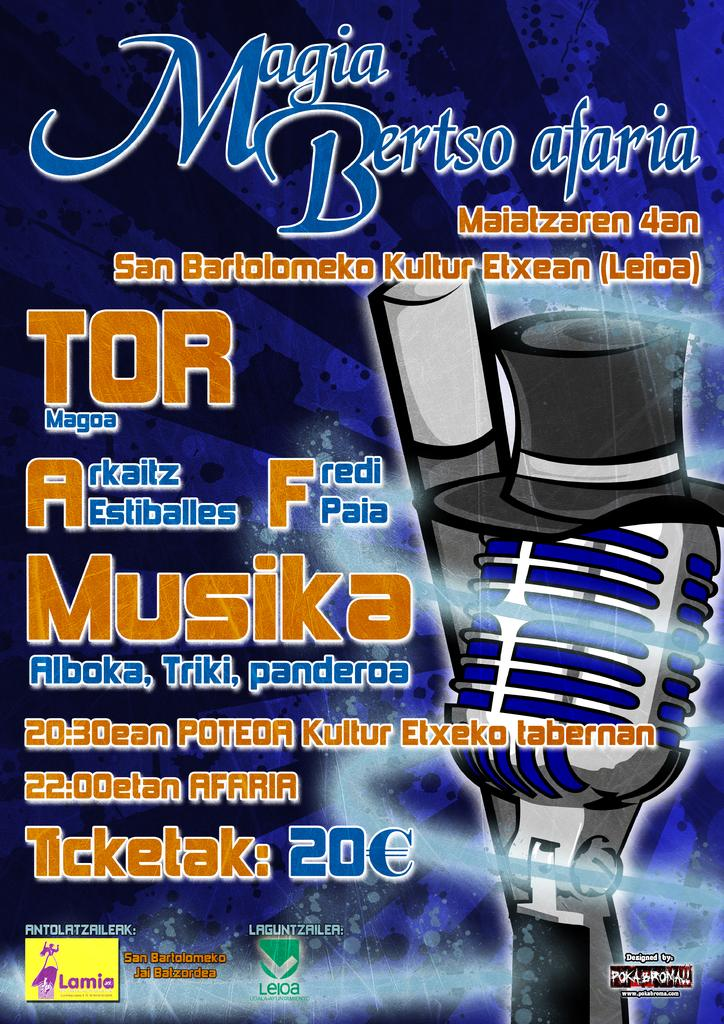<image>
Describe the image concisely. an ad with a microphone that says Magia Bertso afaria is on the page 